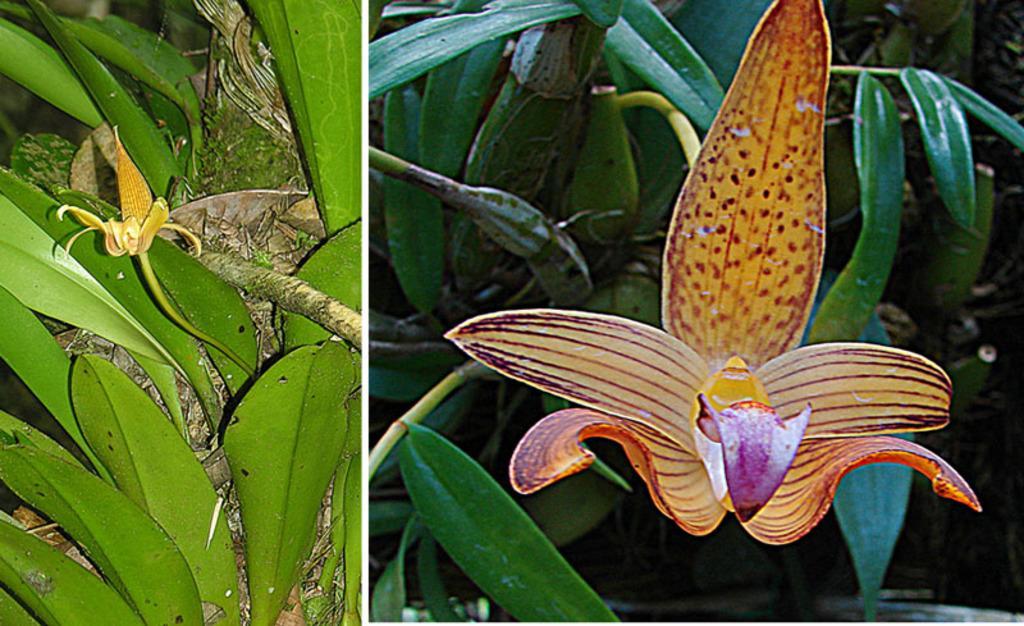Please provide a concise description of this image. In the picture we can see two images, in the first image we can see leaves and small flowers and in the second image we can see a dark green leaves with a big flower with petals and some lines on it. 